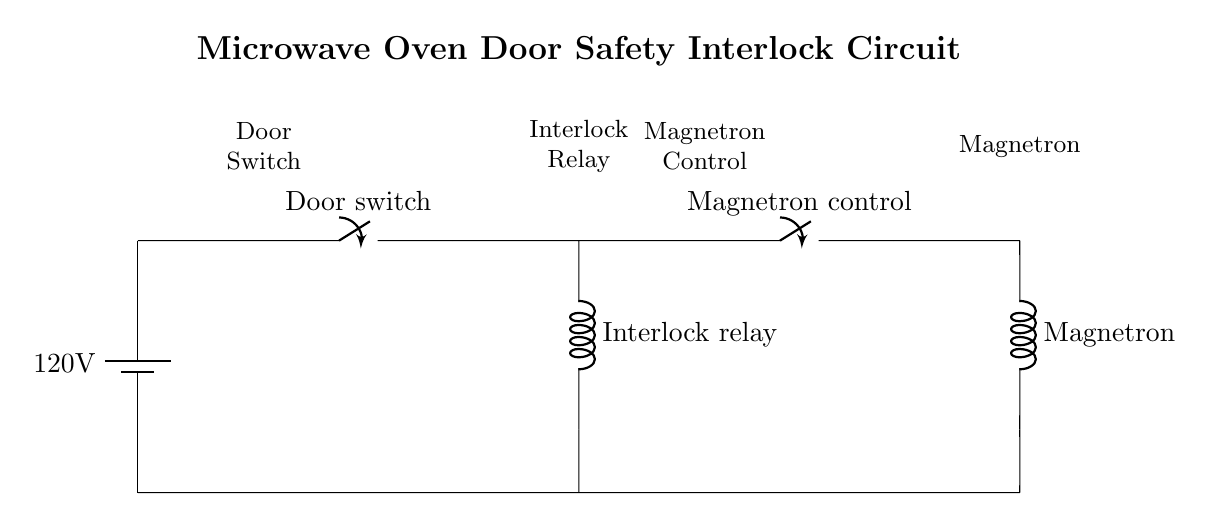What is the voltage of this circuit? The circuit shows a power supply with a labeled voltage of 120V at the battery symbol. This is the source voltage provided to the entire circuit.
Answer: 120V What component is labeled as the door switch? In the circuit diagram, the door switch is represented at the position between the power supply and interlock relay; it is indicated by the switch symbol.
Answer: Door switch What happens if the interlock relay is not activated? The interlock relay connects the door switch to the magnetron control, and if it is not activated, the circuit will not allow current to flow to the magnetron, preventing it from operating.
Answer: No magnetron operation How many main components are there in the circuit? The circuit includes a battery (power supply), a door switch, an interlock relay, a magnetron control switch, and a magnetron itself. Counting these components gives a total of five main components.
Answer: Five components What is the purpose of the interlock relay? The interlock relay ensures that the magnetron cannot function while the microwave door is open, thus enhancing user safety by preventing microwave energy leakage.
Answer: Safety mechanism Which component is responsible for controlling the magnetron? The component labeled as the magnetron control is responsible for managing the operation of the magnetron in the circuit, turning it on or off based on the door's status.
Answer: Magnetron control What is the connection type of the ground connections? In the diagram, the ground connections are shown as short lines connecting to the negative side of the battery and other components, indicating they are connected to a common ground.
Answer: Short connections 